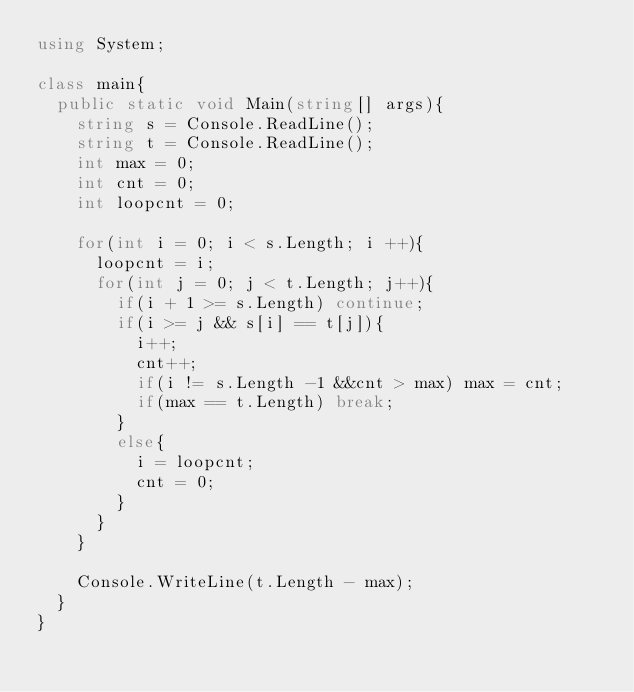Convert code to text. <code><loc_0><loc_0><loc_500><loc_500><_C#_>using System;

class main{
  public static void Main(string[] args){
    string s = Console.ReadLine();
    string t = Console.ReadLine();
    int max = 0;
    int cnt = 0;
    int loopcnt = 0;
    
    for(int i = 0; i < s.Length; i ++){
      loopcnt = i;
      for(int j = 0; j < t.Length; j++){
        if(i + 1 >= s.Length) continue;
        if(i >= j && s[i] == t[j]){
          i++;
          cnt++;
          if(i != s.Length -1 &&cnt > max) max = cnt;
          if(max == t.Length) break;
        }
        else{
          i = loopcnt;
          cnt = 0;
        }
      }
    }
    
    Console.WriteLine(t.Length - max);
  }
}</code> 